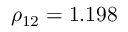<formula> <loc_0><loc_0><loc_500><loc_500>\rho _ { 1 2 } = 1 . 1 9 8</formula> 